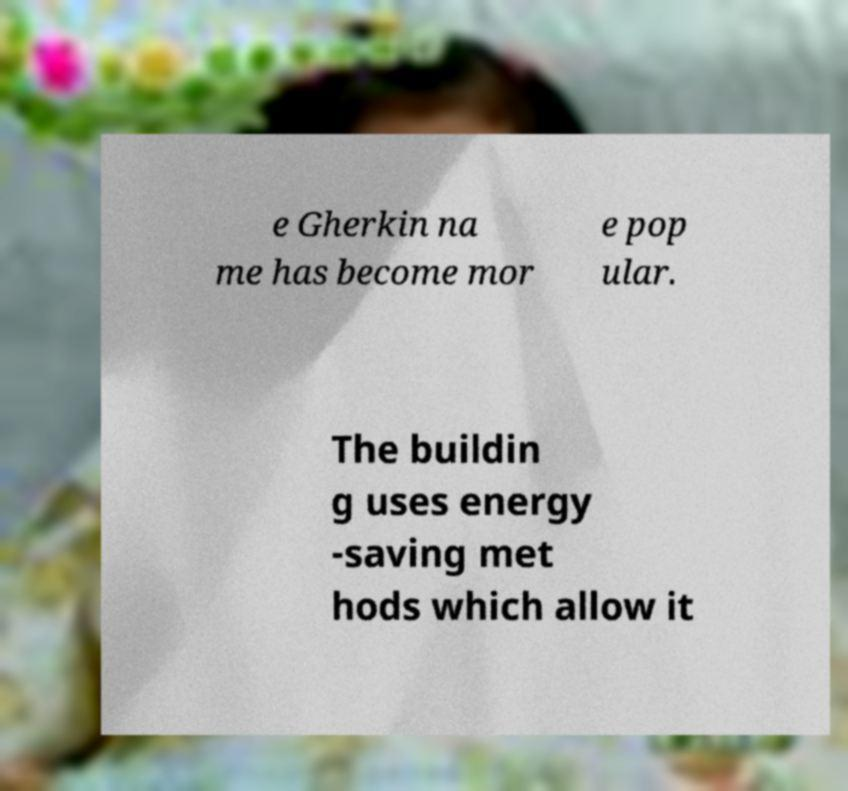What messages or text are displayed in this image? I need them in a readable, typed format. e Gherkin na me has become mor e pop ular. The buildin g uses energy -saving met hods which allow it 